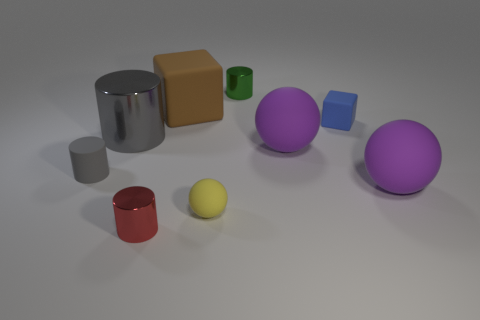Subtract all large rubber spheres. How many spheres are left? 1 Add 1 matte objects. How many objects exist? 10 Subtract all green cylinders. How many cylinders are left? 3 Subtract all cyan cylinders. Subtract all purple cubes. How many cylinders are left? 4 Subtract all spheres. How many objects are left? 6 Subtract 0 brown cylinders. How many objects are left? 9 Subtract all yellow rubber things. Subtract all big things. How many objects are left? 4 Add 6 tiny matte cylinders. How many tiny matte cylinders are left? 7 Add 9 brown metal blocks. How many brown metal blocks exist? 9 